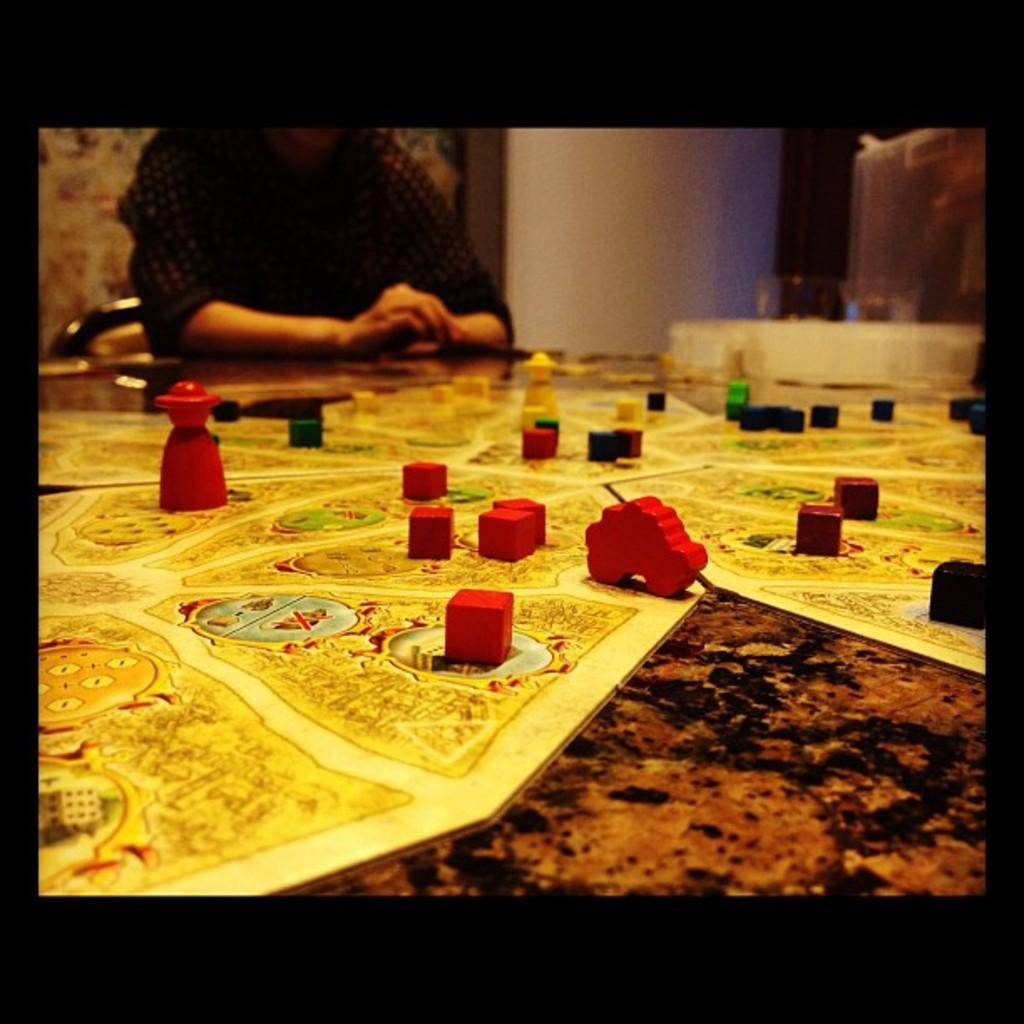What type of objects can be seen in the image? There are blocks and toys on a board in the image. Where is the board with toys located? The board is on a platform. Can you describe the background of the image? There is a person, a chair, a wall, and other objects visible in the background of the image. What type of spade is being used by the person in the image? There is no spade present in the image; the person is not using any tool. How does the whistle sound in the image? There is no whistle present in the image; no sound can be heard. 